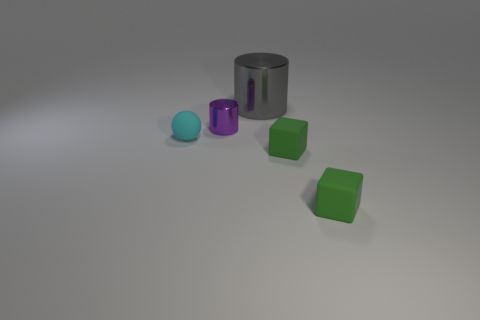How many green blocks must be subtracted to get 1 green blocks? 1 Add 5 purple balls. How many objects exist? 10 Subtract all blue balls. How many cyan cylinders are left? 0 Add 5 tiny green matte cubes. How many tiny green matte cubes are left? 7 Add 3 tiny purple cylinders. How many tiny purple cylinders exist? 4 Subtract 0 gray balls. How many objects are left? 5 Subtract all blocks. How many objects are left? 3 Subtract 1 balls. How many balls are left? 0 Subtract all green cylinders. Subtract all brown spheres. How many cylinders are left? 2 Subtract all large blue matte cylinders. Subtract all cyan objects. How many objects are left? 4 